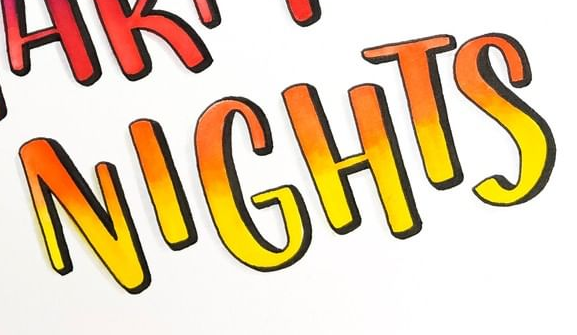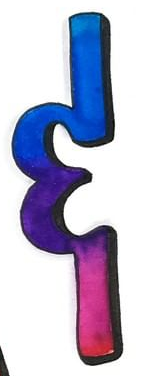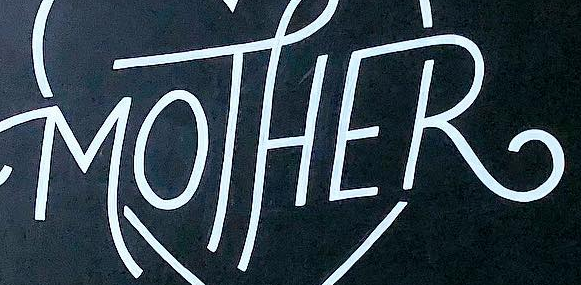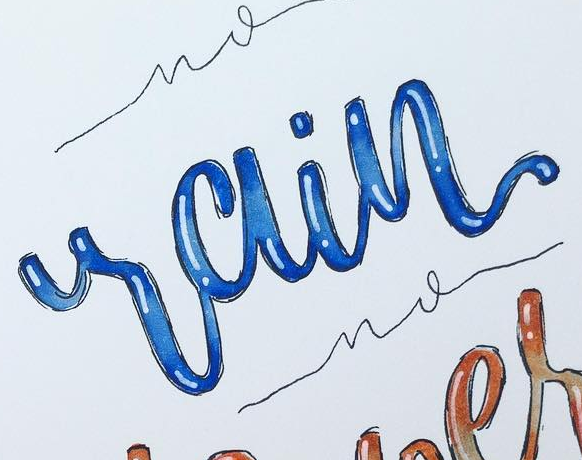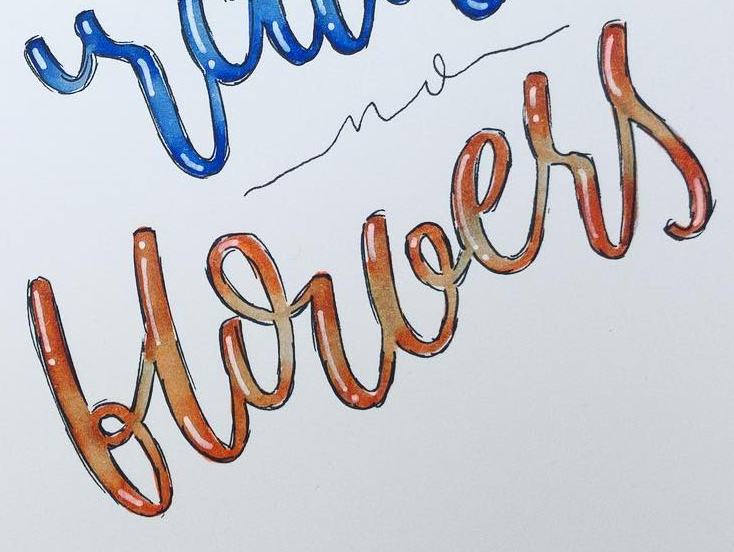What words are shown in these images in order, separated by a semicolon? NIGHTS; &; MOTHER; rain; blouers 